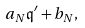<formula> <loc_0><loc_0><loc_500><loc_500>a _ { N } \mathfrak { q } ^ { \prime } + b _ { N } ,</formula> 